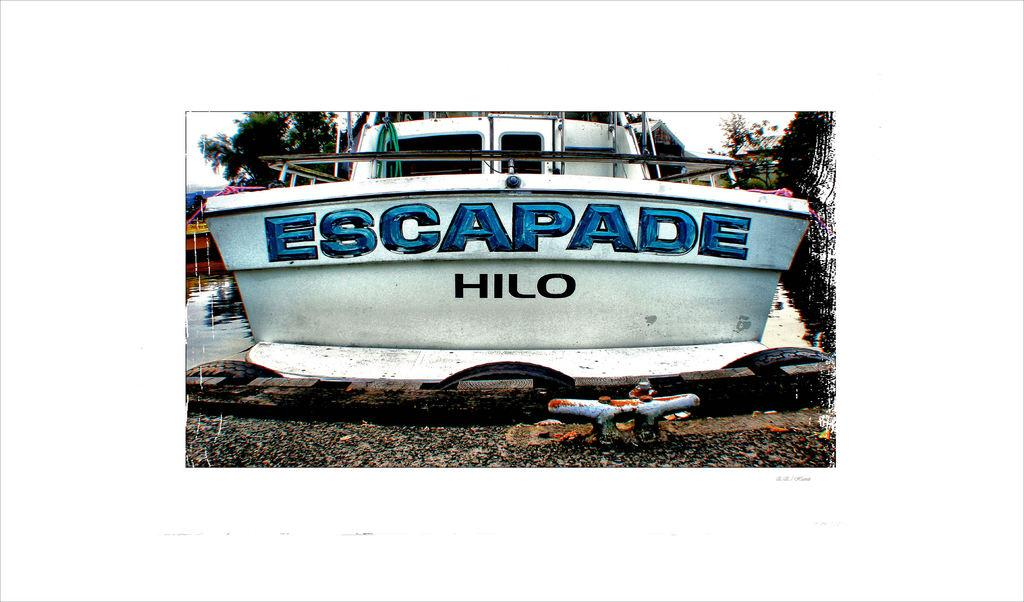<image>
Render a clear and concise summary of the photo. A boat on the water with the tagline Escapade Hilo. 